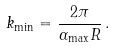<formula> <loc_0><loc_0><loc_500><loc_500>k _ { \min } = \frac { 2 \pi } { \alpha _ { \max } R } \, .</formula> 